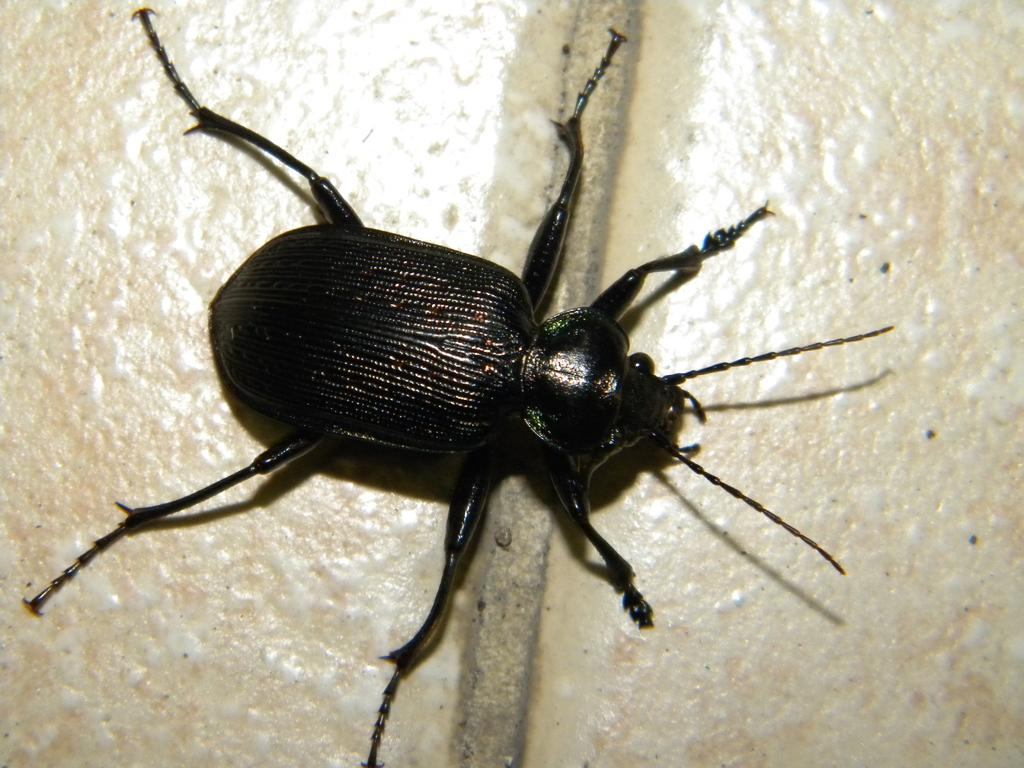What type of insect is in the image? There is a black color insect in the image. Where is the insect located? The insect is on the tiles. What type of furniture is depicted in the image? There is no furniture present in the image; it only features a black color insect on the tiles. What is the temper of the insect in the image? The temper of the insect cannot be determined from the image, as insects do not have emotions like humans. 